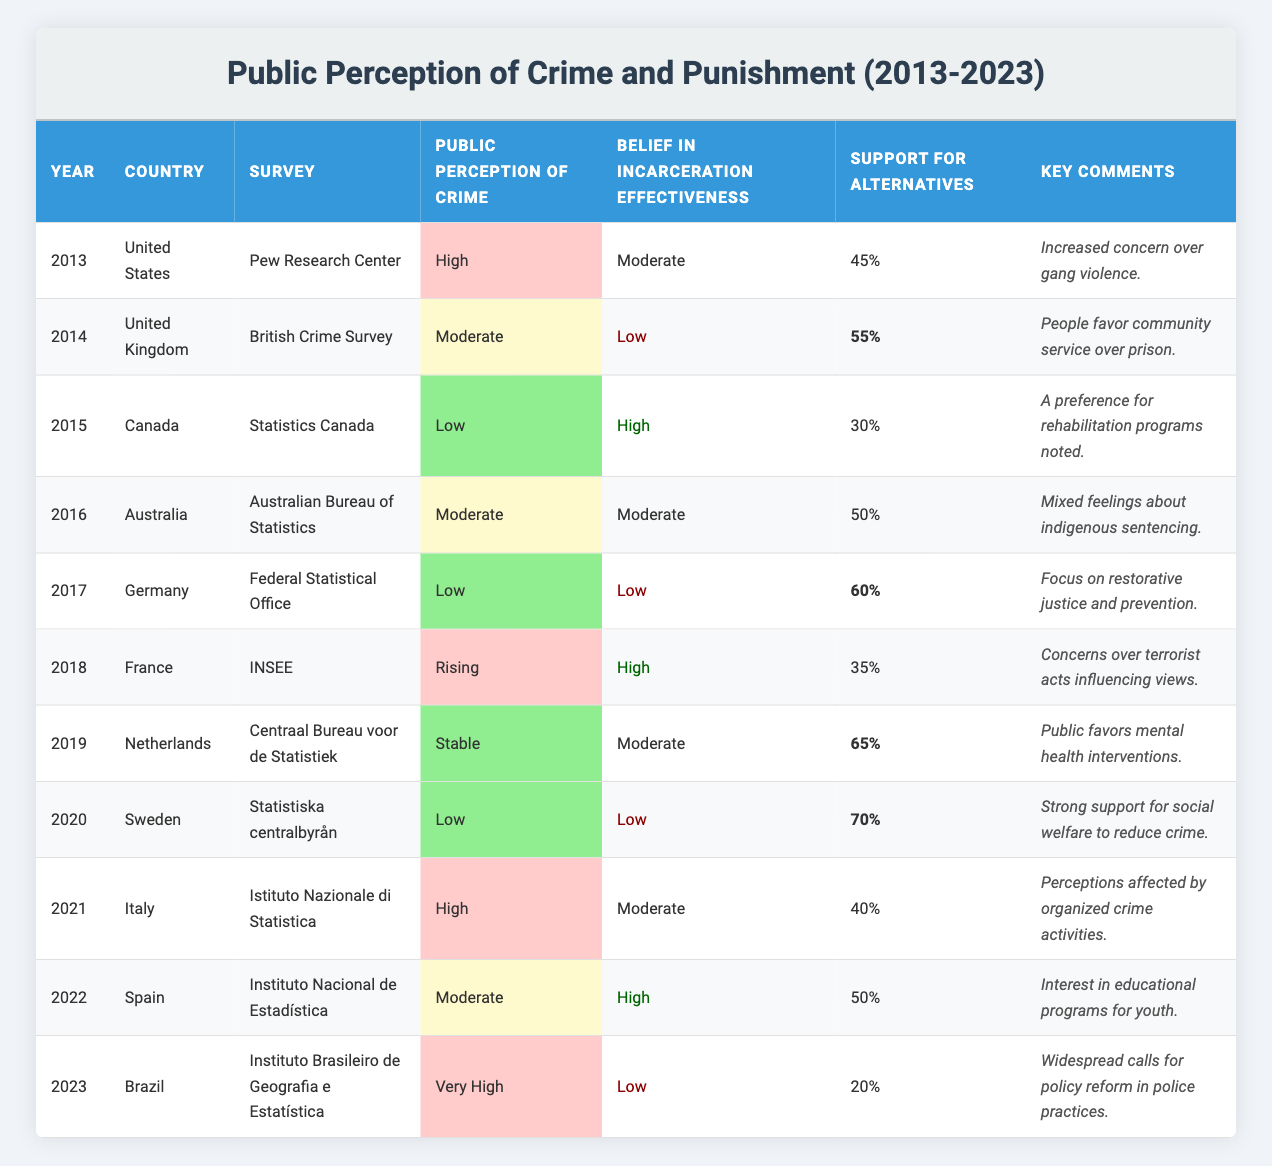What was the public perception of crime in the United States in 2013? The table shows that in 2013, the public perception of crime in the United States was categorized as "High."
Answer: High Which country had the highest support for alternatives to incarceration in 2020? The table indicates that Sweden had the highest support for alternatives at 70% in 2020.
Answer: 70% How many countries reported a "Low" perception of crime in 2015-2020? Analyzing the table, the countries with a "Low" perception of crime during this period are Canada (2015), Germany (2017), Sweden (2020); thus there are three countries.
Answer: 3 Was public belief in incarceration effectiveness high or low in Germany in 2017? In 2017, Germany's public belief in incarceration effectiveness was classified as "Low."
Answer: Low Which country showed an increasing public perception of crime from 2013 to 2023? The table shows that Brazil in 2023 had a "Very High" perception of crime, which indicates an increase in concern from the previous years.
Answer: Brazil What percentage of the public in Canada supported alternatives to incarceration in 2015 and 2016, and which year had higher support? In 2015, Canada had 30% support for alternatives, and in 2016 Australia had 50%. Therefore, comparing the two, Australia had higher support.
Answer: Australia, 50% Did any country report a "Very High" public perception of crime, and if so, which country was it? The table identifies Brazil in 2023 as the country that reported a "Very High" public perception of crime.
Answer: Brazil How does the public belief in incarceration effectiveness in France in 2018 compare to that of Sweden in 2020? In 2018, France had a "High" belief in incarceration effectiveness while Sweden in 2020 had a "Low" belief, showing a decline from France's views to Sweden's views.
Answer: France: High, Sweden: Low Which year saw the lowest support for alternatives to incarceration? Based on the data, Brazil in 2023 at 20% represents the lowest support for alternatives to incarceration compared to other years.
Answer: 20% What trend can be observed regarding public belief in incarceration effectiveness from 2013 to 2023? Analyzing the years from 2013 to 2023, it shows a general decline in belief in incarceration effectiveness, particularly with countries reporting low effectiveness in recent years.
Answer: Decline In which country was there a significant focus on restorative justice and prevention in 2017? The table notes that Germany in 2017 focused on restorative justice and prevention when discussing alternatives to traditional incarceration methods.
Answer: Germany 